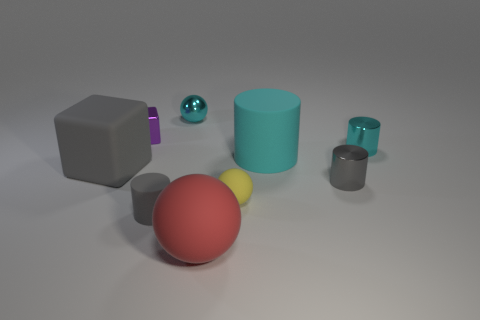Subtract all tiny matte cylinders. How many cylinders are left? 3 Subtract all gray blocks. How many cyan cylinders are left? 2 Subtract all cyan cylinders. How many cylinders are left? 2 Subtract all cylinders. How many objects are left? 5 Subtract 0 brown cylinders. How many objects are left? 9 Subtract 2 blocks. How many blocks are left? 0 Subtract all brown cylinders. Subtract all cyan spheres. How many cylinders are left? 4 Subtract all matte blocks. Subtract all gray rubber balls. How many objects are left? 8 Add 1 matte things. How many matte things are left? 6 Add 7 small shiny cylinders. How many small shiny cylinders exist? 9 